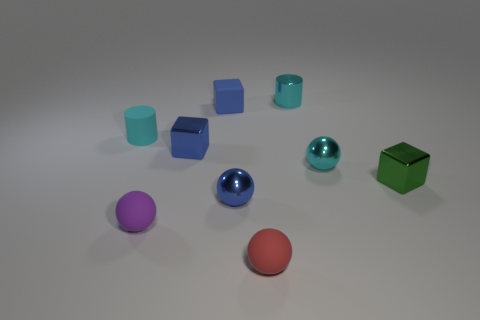Is the cube that is right of the small cyan shiny ball made of the same material as the red thing?
Offer a very short reply. No. How big is the cyan cylinder in front of the blue matte object?
Offer a very short reply. Small. There is a object in front of the purple sphere; are there any blue blocks right of it?
Give a very brief answer. No. There is a shiny block that is left of the tiny cyan metal sphere; does it have the same color as the metal cube that is in front of the blue shiny cube?
Offer a terse response. No. The small metal cylinder is what color?
Your answer should be compact. Cyan. Are there any other things of the same color as the rubber block?
Provide a succinct answer. Yes. The small thing that is both to the right of the small cyan shiny cylinder and left of the small green metal thing is what color?
Offer a terse response. Cyan. Is the size of the block right of the cyan metallic sphere the same as the small blue metallic ball?
Give a very brief answer. Yes. Are there more tiny purple spheres to the right of the small cyan metal cylinder than blue shiny cubes?
Your response must be concise. No. Does the red matte thing have the same shape as the cyan rubber object?
Your answer should be compact. No. 